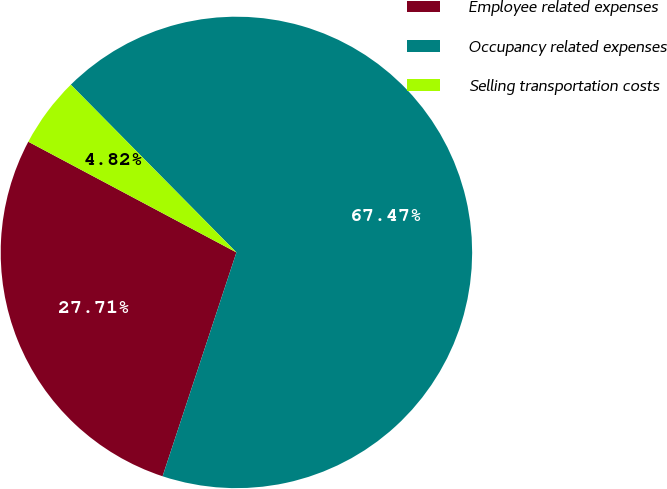Convert chart. <chart><loc_0><loc_0><loc_500><loc_500><pie_chart><fcel>Employee related expenses<fcel>Occupancy related expenses<fcel>Selling transportation costs<nl><fcel>27.71%<fcel>67.47%<fcel>4.82%<nl></chart> 